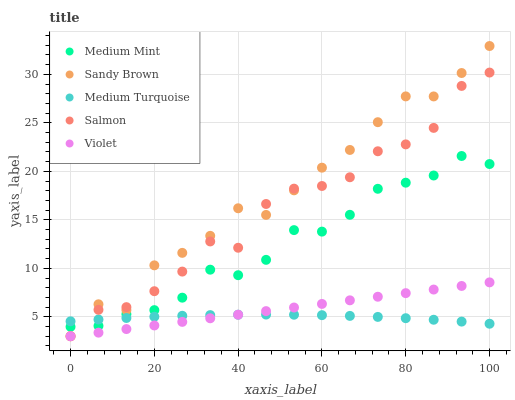Does Medium Turquoise have the minimum area under the curve?
Answer yes or no. Yes. Does Sandy Brown have the maximum area under the curve?
Answer yes or no. Yes. Does Salmon have the minimum area under the curve?
Answer yes or no. No. Does Salmon have the maximum area under the curve?
Answer yes or no. No. Is Violet the smoothest?
Answer yes or no. Yes. Is Salmon the roughest?
Answer yes or no. Yes. Is Sandy Brown the smoothest?
Answer yes or no. No. Is Sandy Brown the roughest?
Answer yes or no. No. Does Salmon have the lowest value?
Answer yes or no. Yes. Does Medium Turquoise have the lowest value?
Answer yes or no. No. Does Sandy Brown have the highest value?
Answer yes or no. Yes. Does Salmon have the highest value?
Answer yes or no. No. Is Violet less than Medium Mint?
Answer yes or no. Yes. Is Medium Mint greater than Violet?
Answer yes or no. Yes. Does Sandy Brown intersect Salmon?
Answer yes or no. Yes. Is Sandy Brown less than Salmon?
Answer yes or no. No. Is Sandy Brown greater than Salmon?
Answer yes or no. No. Does Violet intersect Medium Mint?
Answer yes or no. No. 